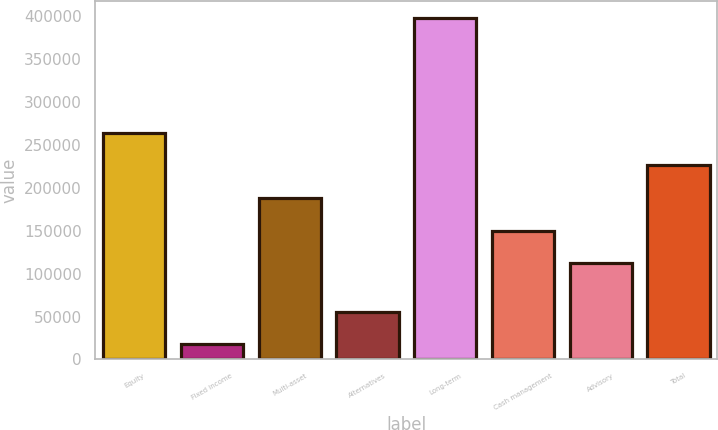Convert chart. <chart><loc_0><loc_0><loc_500><loc_500><bar_chart><fcel>Equity<fcel>Fixed income<fcel>Multi-asset<fcel>Alternatives<fcel>Long-term<fcel>Cash management<fcel>Advisory<fcel>Total<nl><fcel>264206<fcel>17779<fcel>188235<fcel>55764.8<fcel>397637<fcel>150249<fcel>112263<fcel>226220<nl></chart> 